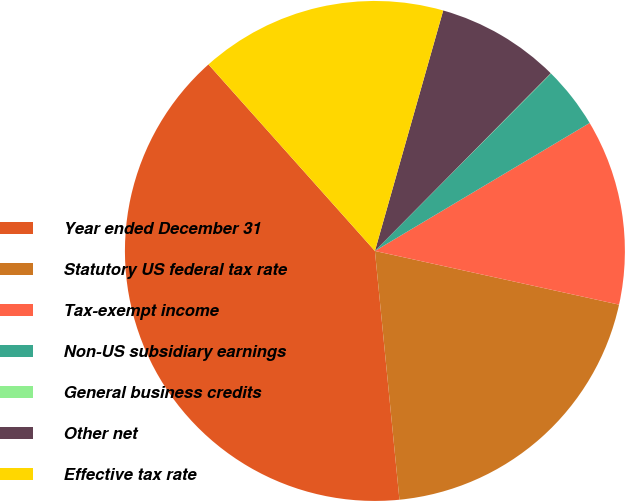Convert chart to OTSL. <chart><loc_0><loc_0><loc_500><loc_500><pie_chart><fcel>Year ended December 31<fcel>Statutory US federal tax rate<fcel>Tax-exempt income<fcel>Non-US subsidiary earnings<fcel>General business credits<fcel>Other net<fcel>Effective tax rate<nl><fcel>39.97%<fcel>19.99%<fcel>12.0%<fcel>4.01%<fcel>0.02%<fcel>8.01%<fcel>16.0%<nl></chart> 